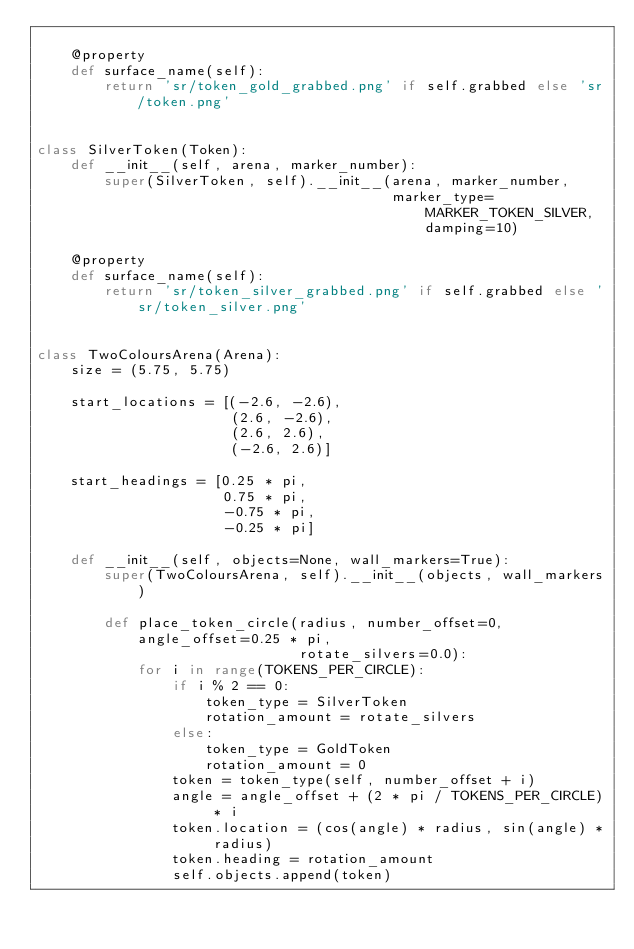<code> <loc_0><loc_0><loc_500><loc_500><_Python_>
    @property
    def surface_name(self):
        return 'sr/token_gold_grabbed.png' if self.grabbed else 'sr/token.png'


class SilverToken(Token):
    def __init__(self, arena, marker_number):
        super(SilverToken, self).__init__(arena, marker_number,
                                          marker_type=MARKER_TOKEN_SILVER, damping=10)

    @property
    def surface_name(self):
        return 'sr/token_silver_grabbed.png' if self.grabbed else 'sr/token_silver.png'


class TwoColoursArena(Arena):
    size = (5.75, 5.75)

    start_locations = [(-2.6, -2.6),
                       (2.6, -2.6),
                       (2.6, 2.6),
                       (-2.6, 2.6)]

    start_headings = [0.25 * pi,
                      0.75 * pi,
                      -0.75 * pi,
                      -0.25 * pi]

    def __init__(self, objects=None, wall_markers=True):
        super(TwoColoursArena, self).__init__(objects, wall_markers)

        def place_token_circle(radius, number_offset=0, angle_offset=0.25 * pi,
                               rotate_silvers=0.0):
            for i in range(TOKENS_PER_CIRCLE):
                if i % 2 == 0:
                    token_type = SilverToken
                    rotation_amount = rotate_silvers
                else:
                    token_type = GoldToken
                    rotation_amount = 0
                token = token_type(self, number_offset + i)
                angle = angle_offset + (2 * pi / TOKENS_PER_CIRCLE) * i
                token.location = (cos(angle) * radius, sin(angle) * radius)
                token.heading = rotation_amount
                self.objects.append(token)
</code> 